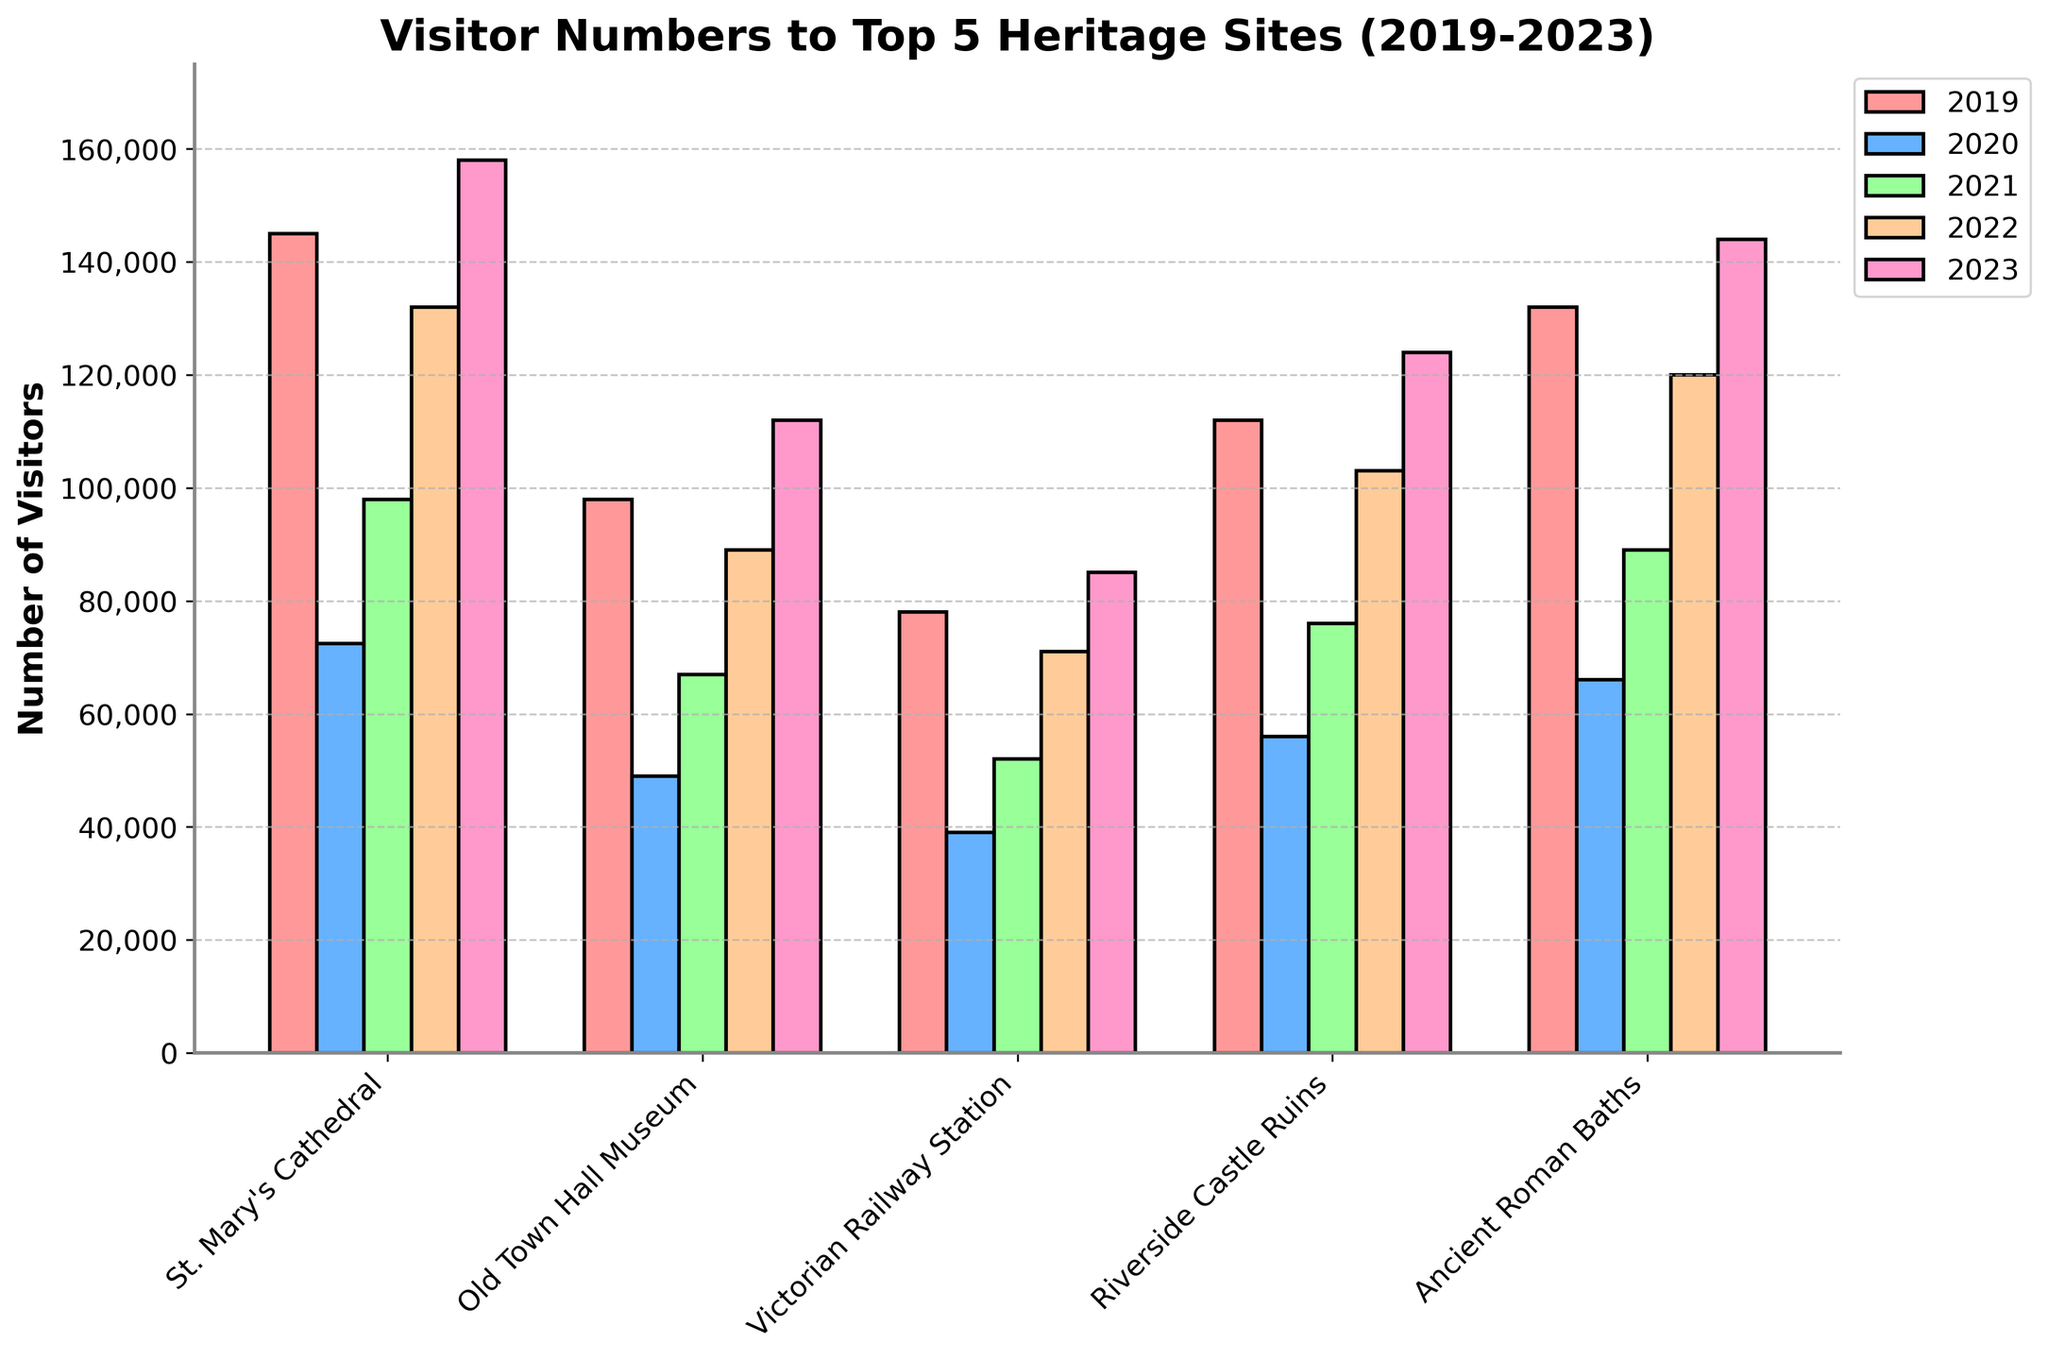Which heritage site had the highest number of visitors in 2023? Identify the highest bar in the 2023 group. St. Mary's Cathedral has the tallest bar.
Answer: St. Mary's Cathedral How many visitors did the Old Town Hall Museum have in 2020 and 2023 combined? Add the number of visitors for the Old Town Hall Museum in 2020 (49,000) to the number of visitors in 2023 (112,000): 49,000 + 112,000 = 161,000.
Answer: 161,000 Which year had the lowest visitor numbers for the Victorian Railway Station? Check the shortest bar for the Victorian Railway Station. The shortest bar is in 2020 with 39,000 visitors.
Answer: 2020 Which site saw the greatest increase in visitor numbers from 2021 to 2022? Calculate the difference in visitors for each site from 2021 to 2022 and determine the largest increase. St. Mary's Cathedral: 132,000 - 98,000 = 34,000, Old Town Hall Museum: 89,000 - 67,000 = 22,000, Victorian Railway Station: 71,000 - 52,000 = 19,000, Riverside Castle Ruins: 103,000 - 76,000 = 27,000, Ancient Roman Baths: 120,000 - 89,000 = 31,000. The greatest increase is for St. Mary's Cathedral (34,000).
Answer: St. Mary's Cathedral What is the average number of visitors to the Riverside Castle Ruins over the past 5 years? Add the visitor numbers for Riverside Castle Ruins: 112,000 + 56,000 + 76,000 + 103,000 + 124,000 = 471,000. Divide by 5 to find the average: 471,000 / 5 = 94,200.
Answer: 94,200 In which year did St. Mary's Cathedral see the steepest decline in visitor numbers? Calculate the changes between each consecutive year's visitor numbers for St. Mary's Cathedral: 2019 to 2020: 145,000 - 72,500 = 72,500, 2020 to 2021: 98,000 - 72,500 = 25,500, 2021 to 2022: 132,000 - 98,000 = 34,000, 2022 to 2023: 158,000 - 132,000 = 26,000. The steepest decline occurs from 2019 to 2020 with 72,500 visitors less.
Answer: 2019 to 2020 Which heritage site has the most consistent visitor numbers over the 5 years? Compare the differences in visitor numbers across the years for each site. The site with the smallest range between the maximum and minimum values is considered the most consistent. Calculate ranges: St. Mary's Cathedral: 158,000 - 72,500 = 85,500, Old Town Hall Museum: 112,000 - 49,000 = 63,000, Victorian Railway Station: 85,000 - 39,000 = 46,000, Riverside Castle Ruins: 124,000 - 56,000 = 68,000, Ancient Roman Baths: 144,000 - 66,000 = 78,000. Victorian Railway Station has the smallest range (46,000).
Answer: Victorian Railway Station Which site had more visitors in 2023, the Ancient Roman Baths or the Riverside Castle Ruins? Compare the visitor numbers for the two sites in 2023. The Ancient Roman Baths had 144,000 visitors, and the Riverside Castle Ruins had 124,000 visitors.
Answer: Ancient Roman Baths 